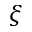Convert formula to latex. <formula><loc_0><loc_0><loc_500><loc_500>\xi</formula> 